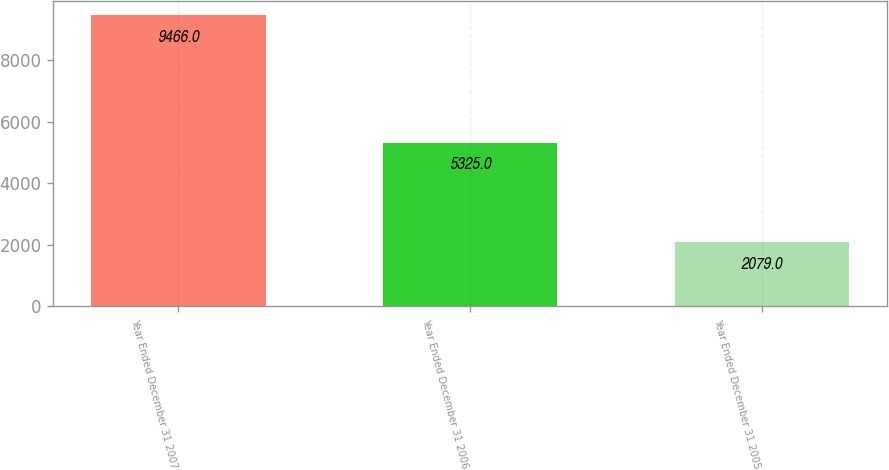<chart> <loc_0><loc_0><loc_500><loc_500><bar_chart><fcel>Year Ended December 31 2007<fcel>Year Ended December 31 2006<fcel>Year Ended December 31 2005<nl><fcel>9466<fcel>5325<fcel>2079<nl></chart> 